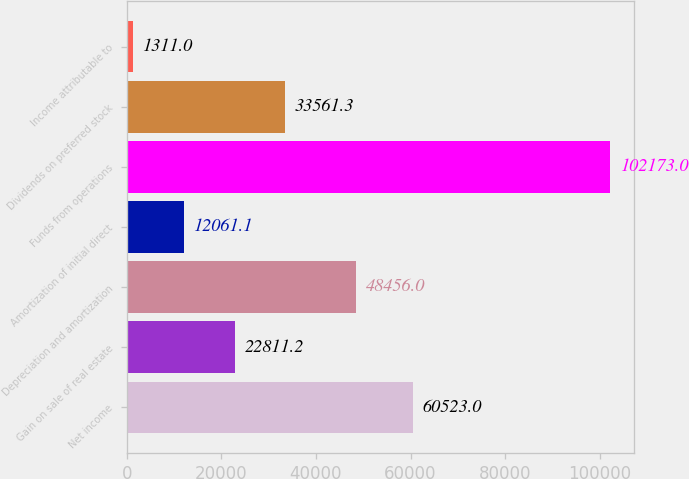Convert chart to OTSL. <chart><loc_0><loc_0><loc_500><loc_500><bar_chart><fcel>Net income<fcel>Gain on sale of real estate<fcel>Depreciation and amortization<fcel>Amortization of initial direct<fcel>Funds from operations<fcel>Dividends on preferred stock<fcel>Income attributable to<nl><fcel>60523<fcel>22811.2<fcel>48456<fcel>12061.1<fcel>102173<fcel>33561.3<fcel>1311<nl></chart> 